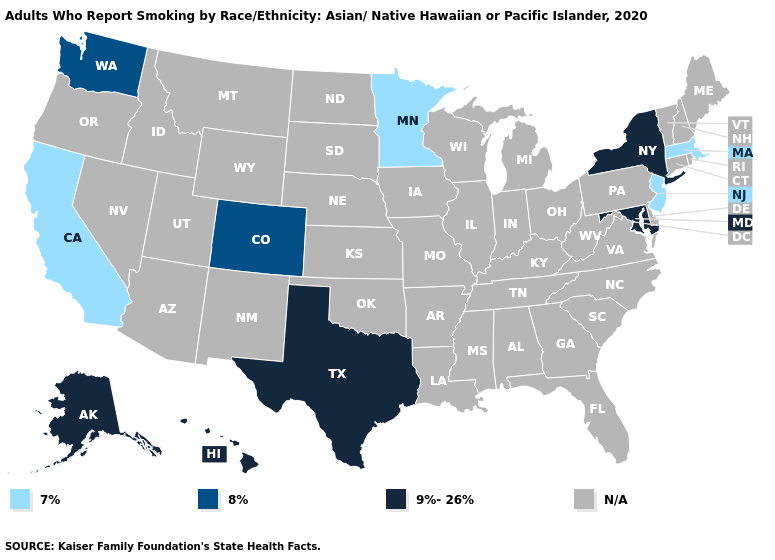What is the highest value in states that border Wisconsin?
Concise answer only. 7%. Which states have the highest value in the USA?
Answer briefly. Alaska, Hawaii, Maryland, New York, Texas. What is the value of Washington?
Short answer required. 8%. What is the value of Hawaii?
Quick response, please. 9%-26%. Which states have the lowest value in the USA?
Short answer required. California, Massachusetts, Minnesota, New Jersey. What is the value of North Dakota?
Quick response, please. N/A. Name the states that have a value in the range 9%-26%?
Short answer required. Alaska, Hawaii, Maryland, New York, Texas. Name the states that have a value in the range N/A?
Concise answer only. Alabama, Arizona, Arkansas, Connecticut, Delaware, Florida, Georgia, Idaho, Illinois, Indiana, Iowa, Kansas, Kentucky, Louisiana, Maine, Michigan, Mississippi, Missouri, Montana, Nebraska, Nevada, New Hampshire, New Mexico, North Carolina, North Dakota, Ohio, Oklahoma, Oregon, Pennsylvania, Rhode Island, South Carolina, South Dakota, Tennessee, Utah, Vermont, Virginia, West Virginia, Wisconsin, Wyoming. What is the lowest value in the MidWest?
Short answer required. 7%. Does the first symbol in the legend represent the smallest category?
Quick response, please. Yes. What is the value of Alaska?
Be succinct. 9%-26%. Which states have the lowest value in the Northeast?
Keep it brief. Massachusetts, New Jersey. Name the states that have a value in the range 8%?
Be succinct. Colorado, Washington. Which states hav the highest value in the South?
Quick response, please. Maryland, Texas. 